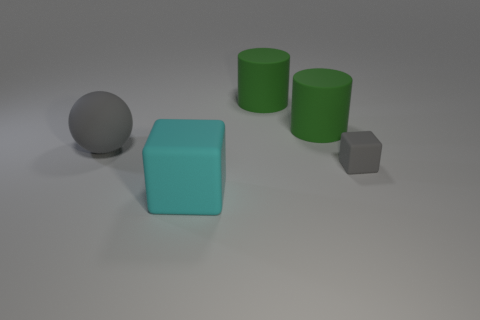Add 2 gray things. How many objects exist? 7 Subtract all cylinders. How many objects are left? 3 Add 2 spheres. How many spheres are left? 3 Add 2 tiny gray rubber cubes. How many tiny gray rubber cubes exist? 3 Subtract 0 blue cubes. How many objects are left? 5 Subtract all tiny red cubes. Subtract all green things. How many objects are left? 3 